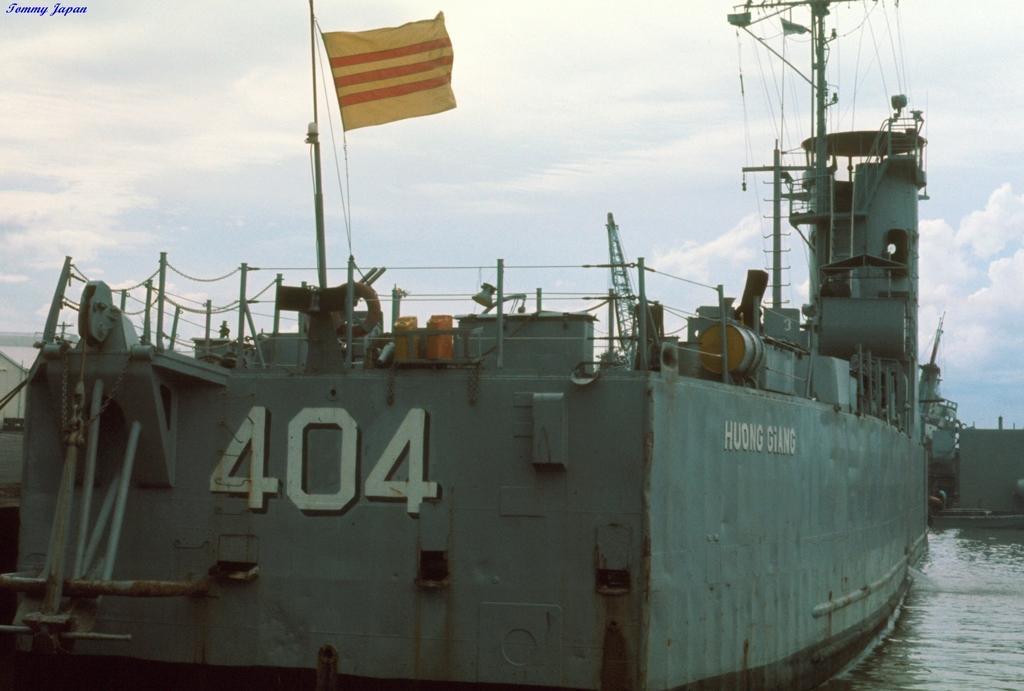Can you describe this image briefly? This image consists of a boat. There is a flag in the middle. There is water at the bottom. There is sky at the top. 